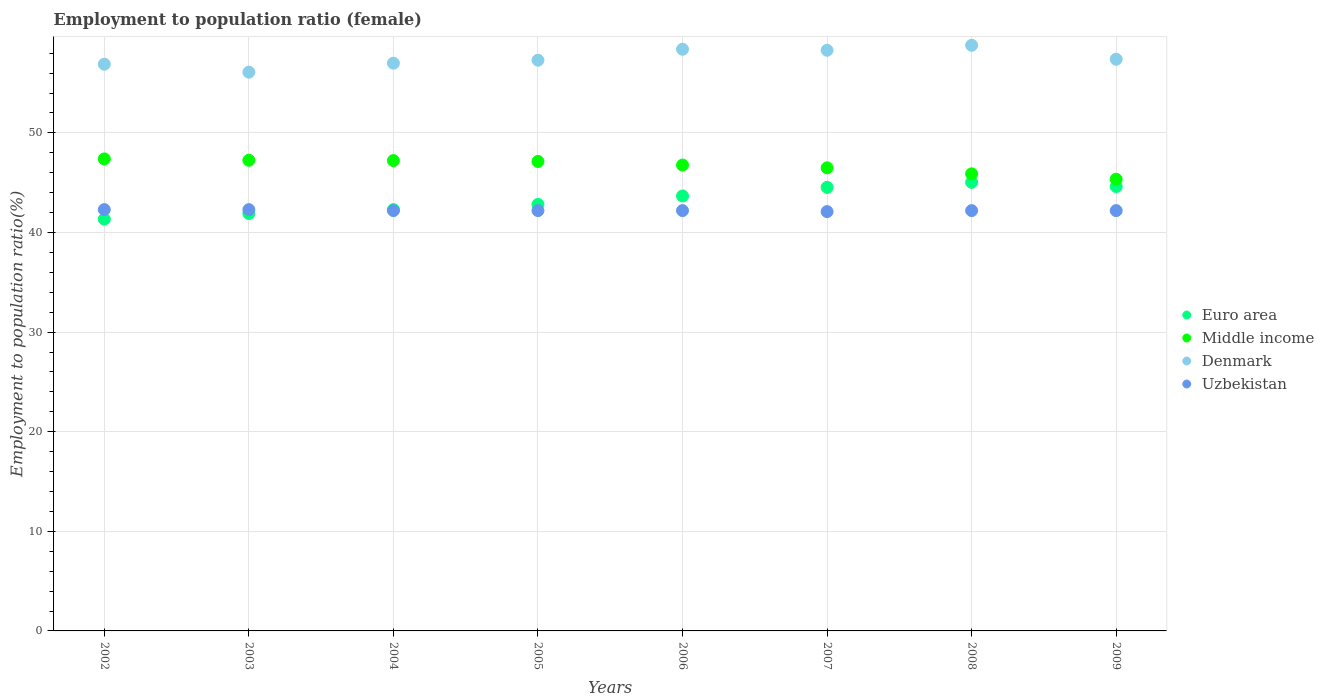How many different coloured dotlines are there?
Your response must be concise. 4. What is the employment to population ratio in Middle income in 2003?
Your answer should be compact. 47.26. Across all years, what is the maximum employment to population ratio in Uzbekistan?
Your response must be concise. 42.3. Across all years, what is the minimum employment to population ratio in Middle income?
Make the answer very short. 45.35. In which year was the employment to population ratio in Denmark minimum?
Provide a succinct answer. 2003. What is the total employment to population ratio in Uzbekistan in the graph?
Ensure brevity in your answer.  337.7. What is the difference between the employment to population ratio in Middle income in 2003 and that in 2004?
Offer a very short reply. 0.04. What is the difference between the employment to population ratio in Euro area in 2006 and the employment to population ratio in Denmark in 2009?
Provide a short and direct response. -13.73. What is the average employment to population ratio in Uzbekistan per year?
Your response must be concise. 42.21. In the year 2005, what is the difference between the employment to population ratio in Uzbekistan and employment to population ratio in Middle income?
Your answer should be compact. -4.93. In how many years, is the employment to population ratio in Denmark greater than 26 %?
Your answer should be compact. 8. What is the ratio of the employment to population ratio in Euro area in 2006 to that in 2009?
Keep it short and to the point. 0.98. Is the employment to population ratio in Denmark in 2004 less than that in 2005?
Ensure brevity in your answer.  Yes. Is the difference between the employment to population ratio in Uzbekistan in 2008 and 2009 greater than the difference between the employment to population ratio in Middle income in 2008 and 2009?
Offer a terse response. No. What is the difference between the highest and the second highest employment to population ratio in Uzbekistan?
Ensure brevity in your answer.  0. What is the difference between the highest and the lowest employment to population ratio in Middle income?
Make the answer very short. 2.04. Is the sum of the employment to population ratio in Denmark in 2003 and 2005 greater than the maximum employment to population ratio in Uzbekistan across all years?
Offer a terse response. Yes. Is the employment to population ratio in Middle income strictly less than the employment to population ratio in Uzbekistan over the years?
Give a very brief answer. No. How many dotlines are there?
Offer a terse response. 4. Are the values on the major ticks of Y-axis written in scientific E-notation?
Offer a terse response. No. Does the graph contain any zero values?
Provide a short and direct response. No. Where does the legend appear in the graph?
Offer a terse response. Center right. How many legend labels are there?
Your answer should be compact. 4. What is the title of the graph?
Ensure brevity in your answer.  Employment to population ratio (female). What is the label or title of the X-axis?
Your answer should be very brief. Years. What is the Employment to population ratio(%) in Euro area in 2002?
Give a very brief answer. 41.34. What is the Employment to population ratio(%) of Middle income in 2002?
Offer a very short reply. 47.39. What is the Employment to population ratio(%) in Denmark in 2002?
Provide a succinct answer. 56.9. What is the Employment to population ratio(%) in Uzbekistan in 2002?
Offer a very short reply. 42.3. What is the Employment to population ratio(%) in Euro area in 2003?
Keep it short and to the point. 41.91. What is the Employment to population ratio(%) of Middle income in 2003?
Your response must be concise. 47.26. What is the Employment to population ratio(%) of Denmark in 2003?
Keep it short and to the point. 56.1. What is the Employment to population ratio(%) of Uzbekistan in 2003?
Provide a succinct answer. 42.3. What is the Employment to population ratio(%) of Euro area in 2004?
Your response must be concise. 42.3. What is the Employment to population ratio(%) of Middle income in 2004?
Offer a terse response. 47.22. What is the Employment to population ratio(%) in Denmark in 2004?
Keep it short and to the point. 57. What is the Employment to population ratio(%) in Uzbekistan in 2004?
Give a very brief answer. 42.2. What is the Employment to population ratio(%) of Euro area in 2005?
Ensure brevity in your answer.  42.82. What is the Employment to population ratio(%) in Middle income in 2005?
Provide a succinct answer. 47.13. What is the Employment to population ratio(%) in Denmark in 2005?
Provide a succinct answer. 57.3. What is the Employment to population ratio(%) of Uzbekistan in 2005?
Provide a succinct answer. 42.2. What is the Employment to population ratio(%) of Euro area in 2006?
Your response must be concise. 43.67. What is the Employment to population ratio(%) in Middle income in 2006?
Your response must be concise. 46.77. What is the Employment to population ratio(%) in Denmark in 2006?
Your response must be concise. 58.4. What is the Employment to population ratio(%) in Uzbekistan in 2006?
Offer a terse response. 42.2. What is the Employment to population ratio(%) of Euro area in 2007?
Your answer should be very brief. 44.53. What is the Employment to population ratio(%) in Middle income in 2007?
Offer a terse response. 46.49. What is the Employment to population ratio(%) in Denmark in 2007?
Give a very brief answer. 58.3. What is the Employment to population ratio(%) in Uzbekistan in 2007?
Provide a short and direct response. 42.1. What is the Employment to population ratio(%) of Euro area in 2008?
Offer a very short reply. 45.04. What is the Employment to population ratio(%) of Middle income in 2008?
Give a very brief answer. 45.89. What is the Employment to population ratio(%) of Denmark in 2008?
Your response must be concise. 58.8. What is the Employment to population ratio(%) in Uzbekistan in 2008?
Your answer should be compact. 42.2. What is the Employment to population ratio(%) of Euro area in 2009?
Give a very brief answer. 44.62. What is the Employment to population ratio(%) of Middle income in 2009?
Your response must be concise. 45.35. What is the Employment to population ratio(%) of Denmark in 2009?
Ensure brevity in your answer.  57.4. What is the Employment to population ratio(%) in Uzbekistan in 2009?
Give a very brief answer. 42.2. Across all years, what is the maximum Employment to population ratio(%) in Euro area?
Ensure brevity in your answer.  45.04. Across all years, what is the maximum Employment to population ratio(%) in Middle income?
Offer a terse response. 47.39. Across all years, what is the maximum Employment to population ratio(%) of Denmark?
Your answer should be very brief. 58.8. Across all years, what is the maximum Employment to population ratio(%) in Uzbekistan?
Your answer should be very brief. 42.3. Across all years, what is the minimum Employment to population ratio(%) in Euro area?
Keep it short and to the point. 41.34. Across all years, what is the minimum Employment to population ratio(%) in Middle income?
Make the answer very short. 45.35. Across all years, what is the minimum Employment to population ratio(%) in Denmark?
Your answer should be compact. 56.1. Across all years, what is the minimum Employment to population ratio(%) of Uzbekistan?
Give a very brief answer. 42.1. What is the total Employment to population ratio(%) in Euro area in the graph?
Ensure brevity in your answer.  346.23. What is the total Employment to population ratio(%) of Middle income in the graph?
Provide a short and direct response. 373.5. What is the total Employment to population ratio(%) in Denmark in the graph?
Offer a terse response. 460.2. What is the total Employment to population ratio(%) of Uzbekistan in the graph?
Your response must be concise. 337.7. What is the difference between the Employment to population ratio(%) of Euro area in 2002 and that in 2003?
Your answer should be very brief. -0.57. What is the difference between the Employment to population ratio(%) in Middle income in 2002 and that in 2003?
Offer a terse response. 0.13. What is the difference between the Employment to population ratio(%) of Euro area in 2002 and that in 2004?
Keep it short and to the point. -0.95. What is the difference between the Employment to population ratio(%) of Middle income in 2002 and that in 2004?
Your answer should be very brief. 0.17. What is the difference between the Employment to population ratio(%) of Euro area in 2002 and that in 2005?
Make the answer very short. -1.48. What is the difference between the Employment to population ratio(%) in Middle income in 2002 and that in 2005?
Make the answer very short. 0.25. What is the difference between the Employment to population ratio(%) in Euro area in 2002 and that in 2006?
Your answer should be compact. -2.33. What is the difference between the Employment to population ratio(%) in Middle income in 2002 and that in 2006?
Keep it short and to the point. 0.62. What is the difference between the Employment to population ratio(%) in Uzbekistan in 2002 and that in 2006?
Make the answer very short. 0.1. What is the difference between the Employment to population ratio(%) of Euro area in 2002 and that in 2007?
Make the answer very short. -3.19. What is the difference between the Employment to population ratio(%) in Middle income in 2002 and that in 2007?
Your response must be concise. 0.89. What is the difference between the Employment to population ratio(%) of Denmark in 2002 and that in 2007?
Provide a short and direct response. -1.4. What is the difference between the Employment to population ratio(%) of Uzbekistan in 2002 and that in 2007?
Provide a short and direct response. 0.2. What is the difference between the Employment to population ratio(%) of Euro area in 2002 and that in 2008?
Keep it short and to the point. -3.7. What is the difference between the Employment to population ratio(%) of Middle income in 2002 and that in 2008?
Offer a terse response. 1.5. What is the difference between the Employment to population ratio(%) of Denmark in 2002 and that in 2008?
Your answer should be very brief. -1.9. What is the difference between the Employment to population ratio(%) of Uzbekistan in 2002 and that in 2008?
Make the answer very short. 0.1. What is the difference between the Employment to population ratio(%) in Euro area in 2002 and that in 2009?
Keep it short and to the point. -3.27. What is the difference between the Employment to population ratio(%) in Middle income in 2002 and that in 2009?
Offer a terse response. 2.04. What is the difference between the Employment to population ratio(%) in Denmark in 2002 and that in 2009?
Offer a very short reply. -0.5. What is the difference between the Employment to population ratio(%) of Uzbekistan in 2002 and that in 2009?
Provide a succinct answer. 0.1. What is the difference between the Employment to population ratio(%) in Euro area in 2003 and that in 2004?
Keep it short and to the point. -0.39. What is the difference between the Employment to population ratio(%) of Middle income in 2003 and that in 2004?
Offer a terse response. 0.04. What is the difference between the Employment to population ratio(%) in Denmark in 2003 and that in 2004?
Offer a terse response. -0.9. What is the difference between the Employment to population ratio(%) of Uzbekistan in 2003 and that in 2004?
Keep it short and to the point. 0.1. What is the difference between the Employment to population ratio(%) in Euro area in 2003 and that in 2005?
Provide a short and direct response. -0.91. What is the difference between the Employment to population ratio(%) in Middle income in 2003 and that in 2005?
Provide a succinct answer. 0.12. What is the difference between the Employment to population ratio(%) of Denmark in 2003 and that in 2005?
Your answer should be compact. -1.2. What is the difference between the Employment to population ratio(%) of Uzbekistan in 2003 and that in 2005?
Make the answer very short. 0.1. What is the difference between the Employment to population ratio(%) of Euro area in 2003 and that in 2006?
Provide a succinct answer. -1.76. What is the difference between the Employment to population ratio(%) of Middle income in 2003 and that in 2006?
Your answer should be very brief. 0.49. What is the difference between the Employment to population ratio(%) in Uzbekistan in 2003 and that in 2006?
Give a very brief answer. 0.1. What is the difference between the Employment to population ratio(%) of Euro area in 2003 and that in 2007?
Provide a short and direct response. -2.62. What is the difference between the Employment to population ratio(%) of Middle income in 2003 and that in 2007?
Offer a terse response. 0.76. What is the difference between the Employment to population ratio(%) of Euro area in 2003 and that in 2008?
Provide a short and direct response. -3.13. What is the difference between the Employment to population ratio(%) in Middle income in 2003 and that in 2008?
Keep it short and to the point. 1.37. What is the difference between the Employment to population ratio(%) in Euro area in 2003 and that in 2009?
Make the answer very short. -2.71. What is the difference between the Employment to population ratio(%) in Middle income in 2003 and that in 2009?
Offer a very short reply. 1.91. What is the difference between the Employment to population ratio(%) of Euro area in 2004 and that in 2005?
Offer a very short reply. -0.52. What is the difference between the Employment to population ratio(%) of Middle income in 2004 and that in 2005?
Give a very brief answer. 0.09. What is the difference between the Employment to population ratio(%) of Euro area in 2004 and that in 2006?
Ensure brevity in your answer.  -1.37. What is the difference between the Employment to population ratio(%) of Middle income in 2004 and that in 2006?
Your response must be concise. 0.45. What is the difference between the Employment to population ratio(%) of Denmark in 2004 and that in 2006?
Your response must be concise. -1.4. What is the difference between the Employment to population ratio(%) in Uzbekistan in 2004 and that in 2006?
Your response must be concise. 0. What is the difference between the Employment to population ratio(%) of Euro area in 2004 and that in 2007?
Your answer should be very brief. -2.24. What is the difference between the Employment to population ratio(%) of Middle income in 2004 and that in 2007?
Provide a short and direct response. 0.73. What is the difference between the Employment to population ratio(%) in Denmark in 2004 and that in 2007?
Your response must be concise. -1.3. What is the difference between the Employment to population ratio(%) in Uzbekistan in 2004 and that in 2007?
Keep it short and to the point. 0.1. What is the difference between the Employment to population ratio(%) in Euro area in 2004 and that in 2008?
Give a very brief answer. -2.74. What is the difference between the Employment to population ratio(%) of Middle income in 2004 and that in 2008?
Your answer should be very brief. 1.33. What is the difference between the Employment to population ratio(%) in Euro area in 2004 and that in 2009?
Keep it short and to the point. -2.32. What is the difference between the Employment to population ratio(%) of Middle income in 2004 and that in 2009?
Make the answer very short. 1.87. What is the difference between the Employment to population ratio(%) of Euro area in 2005 and that in 2006?
Make the answer very short. -0.85. What is the difference between the Employment to population ratio(%) of Middle income in 2005 and that in 2006?
Offer a very short reply. 0.36. What is the difference between the Employment to population ratio(%) in Denmark in 2005 and that in 2006?
Provide a succinct answer. -1.1. What is the difference between the Employment to population ratio(%) in Euro area in 2005 and that in 2007?
Your response must be concise. -1.71. What is the difference between the Employment to population ratio(%) of Middle income in 2005 and that in 2007?
Offer a terse response. 0.64. What is the difference between the Employment to population ratio(%) in Denmark in 2005 and that in 2007?
Your response must be concise. -1. What is the difference between the Employment to population ratio(%) of Euro area in 2005 and that in 2008?
Provide a short and direct response. -2.22. What is the difference between the Employment to population ratio(%) in Middle income in 2005 and that in 2008?
Keep it short and to the point. 1.24. What is the difference between the Employment to population ratio(%) of Denmark in 2005 and that in 2008?
Make the answer very short. -1.5. What is the difference between the Employment to population ratio(%) in Euro area in 2005 and that in 2009?
Make the answer very short. -1.8. What is the difference between the Employment to population ratio(%) of Middle income in 2005 and that in 2009?
Your answer should be very brief. 1.79. What is the difference between the Employment to population ratio(%) in Uzbekistan in 2005 and that in 2009?
Provide a succinct answer. 0. What is the difference between the Employment to population ratio(%) in Euro area in 2006 and that in 2007?
Keep it short and to the point. -0.86. What is the difference between the Employment to population ratio(%) of Middle income in 2006 and that in 2007?
Your answer should be compact. 0.28. What is the difference between the Employment to population ratio(%) of Euro area in 2006 and that in 2008?
Provide a succinct answer. -1.37. What is the difference between the Employment to population ratio(%) in Middle income in 2006 and that in 2008?
Give a very brief answer. 0.88. What is the difference between the Employment to population ratio(%) of Denmark in 2006 and that in 2008?
Provide a succinct answer. -0.4. What is the difference between the Employment to population ratio(%) in Uzbekistan in 2006 and that in 2008?
Your answer should be very brief. 0. What is the difference between the Employment to population ratio(%) of Euro area in 2006 and that in 2009?
Provide a succinct answer. -0.95. What is the difference between the Employment to population ratio(%) in Middle income in 2006 and that in 2009?
Your response must be concise. 1.42. What is the difference between the Employment to population ratio(%) in Denmark in 2006 and that in 2009?
Ensure brevity in your answer.  1. What is the difference between the Employment to population ratio(%) in Uzbekistan in 2006 and that in 2009?
Your answer should be very brief. 0. What is the difference between the Employment to population ratio(%) of Euro area in 2007 and that in 2008?
Offer a terse response. -0.51. What is the difference between the Employment to population ratio(%) of Middle income in 2007 and that in 2008?
Your answer should be compact. 0.6. What is the difference between the Employment to population ratio(%) of Euro area in 2007 and that in 2009?
Your answer should be compact. -0.08. What is the difference between the Employment to population ratio(%) of Middle income in 2007 and that in 2009?
Provide a succinct answer. 1.15. What is the difference between the Employment to population ratio(%) of Denmark in 2007 and that in 2009?
Your response must be concise. 0.9. What is the difference between the Employment to population ratio(%) of Uzbekistan in 2007 and that in 2009?
Your answer should be compact. -0.1. What is the difference between the Employment to population ratio(%) in Euro area in 2008 and that in 2009?
Ensure brevity in your answer.  0.42. What is the difference between the Employment to population ratio(%) of Middle income in 2008 and that in 2009?
Ensure brevity in your answer.  0.55. What is the difference between the Employment to population ratio(%) in Denmark in 2008 and that in 2009?
Keep it short and to the point. 1.4. What is the difference between the Employment to population ratio(%) of Euro area in 2002 and the Employment to population ratio(%) of Middle income in 2003?
Offer a terse response. -5.91. What is the difference between the Employment to population ratio(%) of Euro area in 2002 and the Employment to population ratio(%) of Denmark in 2003?
Keep it short and to the point. -14.76. What is the difference between the Employment to population ratio(%) in Euro area in 2002 and the Employment to population ratio(%) in Uzbekistan in 2003?
Provide a succinct answer. -0.96. What is the difference between the Employment to population ratio(%) of Middle income in 2002 and the Employment to population ratio(%) of Denmark in 2003?
Give a very brief answer. -8.71. What is the difference between the Employment to population ratio(%) in Middle income in 2002 and the Employment to population ratio(%) in Uzbekistan in 2003?
Provide a short and direct response. 5.09. What is the difference between the Employment to population ratio(%) in Denmark in 2002 and the Employment to population ratio(%) in Uzbekistan in 2003?
Provide a succinct answer. 14.6. What is the difference between the Employment to population ratio(%) in Euro area in 2002 and the Employment to population ratio(%) in Middle income in 2004?
Provide a short and direct response. -5.88. What is the difference between the Employment to population ratio(%) in Euro area in 2002 and the Employment to population ratio(%) in Denmark in 2004?
Your answer should be compact. -15.66. What is the difference between the Employment to population ratio(%) in Euro area in 2002 and the Employment to population ratio(%) in Uzbekistan in 2004?
Offer a terse response. -0.86. What is the difference between the Employment to population ratio(%) in Middle income in 2002 and the Employment to population ratio(%) in Denmark in 2004?
Provide a short and direct response. -9.61. What is the difference between the Employment to population ratio(%) of Middle income in 2002 and the Employment to population ratio(%) of Uzbekistan in 2004?
Provide a short and direct response. 5.19. What is the difference between the Employment to population ratio(%) in Euro area in 2002 and the Employment to population ratio(%) in Middle income in 2005?
Provide a succinct answer. -5.79. What is the difference between the Employment to population ratio(%) in Euro area in 2002 and the Employment to population ratio(%) in Denmark in 2005?
Keep it short and to the point. -15.96. What is the difference between the Employment to population ratio(%) of Euro area in 2002 and the Employment to population ratio(%) of Uzbekistan in 2005?
Keep it short and to the point. -0.86. What is the difference between the Employment to population ratio(%) of Middle income in 2002 and the Employment to population ratio(%) of Denmark in 2005?
Offer a very short reply. -9.91. What is the difference between the Employment to population ratio(%) in Middle income in 2002 and the Employment to population ratio(%) in Uzbekistan in 2005?
Your response must be concise. 5.19. What is the difference between the Employment to population ratio(%) in Denmark in 2002 and the Employment to population ratio(%) in Uzbekistan in 2005?
Offer a terse response. 14.7. What is the difference between the Employment to population ratio(%) of Euro area in 2002 and the Employment to population ratio(%) of Middle income in 2006?
Provide a short and direct response. -5.43. What is the difference between the Employment to population ratio(%) of Euro area in 2002 and the Employment to population ratio(%) of Denmark in 2006?
Keep it short and to the point. -17.06. What is the difference between the Employment to population ratio(%) in Euro area in 2002 and the Employment to population ratio(%) in Uzbekistan in 2006?
Give a very brief answer. -0.86. What is the difference between the Employment to population ratio(%) of Middle income in 2002 and the Employment to population ratio(%) of Denmark in 2006?
Offer a very short reply. -11.01. What is the difference between the Employment to population ratio(%) in Middle income in 2002 and the Employment to population ratio(%) in Uzbekistan in 2006?
Provide a succinct answer. 5.19. What is the difference between the Employment to population ratio(%) in Denmark in 2002 and the Employment to population ratio(%) in Uzbekistan in 2006?
Keep it short and to the point. 14.7. What is the difference between the Employment to population ratio(%) of Euro area in 2002 and the Employment to population ratio(%) of Middle income in 2007?
Offer a terse response. -5.15. What is the difference between the Employment to population ratio(%) of Euro area in 2002 and the Employment to population ratio(%) of Denmark in 2007?
Provide a succinct answer. -16.96. What is the difference between the Employment to population ratio(%) in Euro area in 2002 and the Employment to population ratio(%) in Uzbekistan in 2007?
Offer a very short reply. -0.76. What is the difference between the Employment to population ratio(%) in Middle income in 2002 and the Employment to population ratio(%) in Denmark in 2007?
Offer a very short reply. -10.91. What is the difference between the Employment to population ratio(%) in Middle income in 2002 and the Employment to population ratio(%) in Uzbekistan in 2007?
Provide a succinct answer. 5.29. What is the difference between the Employment to population ratio(%) of Denmark in 2002 and the Employment to population ratio(%) of Uzbekistan in 2007?
Keep it short and to the point. 14.8. What is the difference between the Employment to population ratio(%) of Euro area in 2002 and the Employment to population ratio(%) of Middle income in 2008?
Your response must be concise. -4.55. What is the difference between the Employment to population ratio(%) of Euro area in 2002 and the Employment to population ratio(%) of Denmark in 2008?
Ensure brevity in your answer.  -17.46. What is the difference between the Employment to population ratio(%) in Euro area in 2002 and the Employment to population ratio(%) in Uzbekistan in 2008?
Provide a succinct answer. -0.86. What is the difference between the Employment to population ratio(%) in Middle income in 2002 and the Employment to population ratio(%) in Denmark in 2008?
Keep it short and to the point. -11.41. What is the difference between the Employment to population ratio(%) of Middle income in 2002 and the Employment to population ratio(%) of Uzbekistan in 2008?
Offer a very short reply. 5.19. What is the difference between the Employment to population ratio(%) of Denmark in 2002 and the Employment to population ratio(%) of Uzbekistan in 2008?
Your answer should be very brief. 14.7. What is the difference between the Employment to population ratio(%) of Euro area in 2002 and the Employment to population ratio(%) of Middle income in 2009?
Provide a succinct answer. -4. What is the difference between the Employment to population ratio(%) in Euro area in 2002 and the Employment to population ratio(%) in Denmark in 2009?
Your response must be concise. -16.06. What is the difference between the Employment to population ratio(%) of Euro area in 2002 and the Employment to population ratio(%) of Uzbekistan in 2009?
Your response must be concise. -0.86. What is the difference between the Employment to population ratio(%) in Middle income in 2002 and the Employment to population ratio(%) in Denmark in 2009?
Your answer should be very brief. -10.01. What is the difference between the Employment to population ratio(%) in Middle income in 2002 and the Employment to population ratio(%) in Uzbekistan in 2009?
Offer a very short reply. 5.19. What is the difference between the Employment to population ratio(%) in Denmark in 2002 and the Employment to population ratio(%) in Uzbekistan in 2009?
Make the answer very short. 14.7. What is the difference between the Employment to population ratio(%) of Euro area in 2003 and the Employment to population ratio(%) of Middle income in 2004?
Your answer should be very brief. -5.31. What is the difference between the Employment to population ratio(%) in Euro area in 2003 and the Employment to population ratio(%) in Denmark in 2004?
Ensure brevity in your answer.  -15.09. What is the difference between the Employment to population ratio(%) in Euro area in 2003 and the Employment to population ratio(%) in Uzbekistan in 2004?
Make the answer very short. -0.29. What is the difference between the Employment to population ratio(%) in Middle income in 2003 and the Employment to population ratio(%) in Denmark in 2004?
Give a very brief answer. -9.74. What is the difference between the Employment to population ratio(%) in Middle income in 2003 and the Employment to population ratio(%) in Uzbekistan in 2004?
Provide a short and direct response. 5.06. What is the difference between the Employment to population ratio(%) of Denmark in 2003 and the Employment to population ratio(%) of Uzbekistan in 2004?
Ensure brevity in your answer.  13.9. What is the difference between the Employment to population ratio(%) in Euro area in 2003 and the Employment to population ratio(%) in Middle income in 2005?
Ensure brevity in your answer.  -5.23. What is the difference between the Employment to population ratio(%) of Euro area in 2003 and the Employment to population ratio(%) of Denmark in 2005?
Provide a short and direct response. -15.39. What is the difference between the Employment to population ratio(%) of Euro area in 2003 and the Employment to population ratio(%) of Uzbekistan in 2005?
Offer a terse response. -0.29. What is the difference between the Employment to population ratio(%) of Middle income in 2003 and the Employment to population ratio(%) of Denmark in 2005?
Give a very brief answer. -10.04. What is the difference between the Employment to population ratio(%) in Middle income in 2003 and the Employment to population ratio(%) in Uzbekistan in 2005?
Offer a very short reply. 5.06. What is the difference between the Employment to population ratio(%) of Euro area in 2003 and the Employment to population ratio(%) of Middle income in 2006?
Give a very brief answer. -4.86. What is the difference between the Employment to population ratio(%) in Euro area in 2003 and the Employment to population ratio(%) in Denmark in 2006?
Your response must be concise. -16.49. What is the difference between the Employment to population ratio(%) in Euro area in 2003 and the Employment to population ratio(%) in Uzbekistan in 2006?
Give a very brief answer. -0.29. What is the difference between the Employment to population ratio(%) in Middle income in 2003 and the Employment to population ratio(%) in Denmark in 2006?
Give a very brief answer. -11.14. What is the difference between the Employment to population ratio(%) of Middle income in 2003 and the Employment to population ratio(%) of Uzbekistan in 2006?
Your answer should be compact. 5.06. What is the difference between the Employment to population ratio(%) of Euro area in 2003 and the Employment to population ratio(%) of Middle income in 2007?
Your answer should be very brief. -4.59. What is the difference between the Employment to population ratio(%) of Euro area in 2003 and the Employment to population ratio(%) of Denmark in 2007?
Offer a very short reply. -16.39. What is the difference between the Employment to population ratio(%) in Euro area in 2003 and the Employment to population ratio(%) in Uzbekistan in 2007?
Offer a very short reply. -0.19. What is the difference between the Employment to population ratio(%) in Middle income in 2003 and the Employment to population ratio(%) in Denmark in 2007?
Provide a succinct answer. -11.04. What is the difference between the Employment to population ratio(%) of Middle income in 2003 and the Employment to population ratio(%) of Uzbekistan in 2007?
Keep it short and to the point. 5.16. What is the difference between the Employment to population ratio(%) of Denmark in 2003 and the Employment to population ratio(%) of Uzbekistan in 2007?
Make the answer very short. 14. What is the difference between the Employment to population ratio(%) in Euro area in 2003 and the Employment to population ratio(%) in Middle income in 2008?
Provide a short and direct response. -3.98. What is the difference between the Employment to population ratio(%) in Euro area in 2003 and the Employment to population ratio(%) in Denmark in 2008?
Ensure brevity in your answer.  -16.89. What is the difference between the Employment to population ratio(%) in Euro area in 2003 and the Employment to population ratio(%) in Uzbekistan in 2008?
Provide a short and direct response. -0.29. What is the difference between the Employment to population ratio(%) in Middle income in 2003 and the Employment to population ratio(%) in Denmark in 2008?
Offer a very short reply. -11.54. What is the difference between the Employment to population ratio(%) of Middle income in 2003 and the Employment to population ratio(%) of Uzbekistan in 2008?
Offer a terse response. 5.06. What is the difference between the Employment to population ratio(%) in Denmark in 2003 and the Employment to population ratio(%) in Uzbekistan in 2008?
Keep it short and to the point. 13.9. What is the difference between the Employment to population ratio(%) in Euro area in 2003 and the Employment to population ratio(%) in Middle income in 2009?
Your response must be concise. -3.44. What is the difference between the Employment to population ratio(%) in Euro area in 2003 and the Employment to population ratio(%) in Denmark in 2009?
Ensure brevity in your answer.  -15.49. What is the difference between the Employment to population ratio(%) of Euro area in 2003 and the Employment to population ratio(%) of Uzbekistan in 2009?
Make the answer very short. -0.29. What is the difference between the Employment to population ratio(%) in Middle income in 2003 and the Employment to population ratio(%) in Denmark in 2009?
Your response must be concise. -10.14. What is the difference between the Employment to population ratio(%) in Middle income in 2003 and the Employment to population ratio(%) in Uzbekistan in 2009?
Keep it short and to the point. 5.06. What is the difference between the Employment to population ratio(%) in Euro area in 2004 and the Employment to population ratio(%) in Middle income in 2005?
Offer a terse response. -4.84. What is the difference between the Employment to population ratio(%) of Euro area in 2004 and the Employment to population ratio(%) of Denmark in 2005?
Keep it short and to the point. -15. What is the difference between the Employment to population ratio(%) in Euro area in 2004 and the Employment to population ratio(%) in Uzbekistan in 2005?
Give a very brief answer. 0.1. What is the difference between the Employment to population ratio(%) of Middle income in 2004 and the Employment to population ratio(%) of Denmark in 2005?
Your answer should be very brief. -10.08. What is the difference between the Employment to population ratio(%) in Middle income in 2004 and the Employment to population ratio(%) in Uzbekistan in 2005?
Provide a succinct answer. 5.02. What is the difference between the Employment to population ratio(%) of Euro area in 2004 and the Employment to population ratio(%) of Middle income in 2006?
Your answer should be compact. -4.47. What is the difference between the Employment to population ratio(%) in Euro area in 2004 and the Employment to population ratio(%) in Denmark in 2006?
Your answer should be very brief. -16.1. What is the difference between the Employment to population ratio(%) of Euro area in 2004 and the Employment to population ratio(%) of Uzbekistan in 2006?
Your response must be concise. 0.1. What is the difference between the Employment to population ratio(%) in Middle income in 2004 and the Employment to population ratio(%) in Denmark in 2006?
Keep it short and to the point. -11.18. What is the difference between the Employment to population ratio(%) in Middle income in 2004 and the Employment to population ratio(%) in Uzbekistan in 2006?
Provide a succinct answer. 5.02. What is the difference between the Employment to population ratio(%) of Denmark in 2004 and the Employment to population ratio(%) of Uzbekistan in 2006?
Your answer should be compact. 14.8. What is the difference between the Employment to population ratio(%) of Euro area in 2004 and the Employment to population ratio(%) of Middle income in 2007?
Ensure brevity in your answer.  -4.2. What is the difference between the Employment to population ratio(%) of Euro area in 2004 and the Employment to population ratio(%) of Denmark in 2007?
Offer a terse response. -16. What is the difference between the Employment to population ratio(%) of Euro area in 2004 and the Employment to population ratio(%) of Uzbekistan in 2007?
Offer a terse response. 0.2. What is the difference between the Employment to population ratio(%) in Middle income in 2004 and the Employment to population ratio(%) in Denmark in 2007?
Your answer should be compact. -11.08. What is the difference between the Employment to population ratio(%) of Middle income in 2004 and the Employment to population ratio(%) of Uzbekistan in 2007?
Ensure brevity in your answer.  5.12. What is the difference between the Employment to population ratio(%) of Euro area in 2004 and the Employment to population ratio(%) of Middle income in 2008?
Offer a terse response. -3.59. What is the difference between the Employment to population ratio(%) of Euro area in 2004 and the Employment to population ratio(%) of Denmark in 2008?
Your answer should be compact. -16.5. What is the difference between the Employment to population ratio(%) of Euro area in 2004 and the Employment to population ratio(%) of Uzbekistan in 2008?
Your answer should be very brief. 0.1. What is the difference between the Employment to population ratio(%) in Middle income in 2004 and the Employment to population ratio(%) in Denmark in 2008?
Your answer should be very brief. -11.58. What is the difference between the Employment to population ratio(%) of Middle income in 2004 and the Employment to population ratio(%) of Uzbekistan in 2008?
Your response must be concise. 5.02. What is the difference between the Employment to population ratio(%) in Denmark in 2004 and the Employment to population ratio(%) in Uzbekistan in 2008?
Make the answer very short. 14.8. What is the difference between the Employment to population ratio(%) of Euro area in 2004 and the Employment to population ratio(%) of Middle income in 2009?
Provide a short and direct response. -3.05. What is the difference between the Employment to population ratio(%) in Euro area in 2004 and the Employment to population ratio(%) in Denmark in 2009?
Your answer should be compact. -15.1. What is the difference between the Employment to population ratio(%) of Euro area in 2004 and the Employment to population ratio(%) of Uzbekistan in 2009?
Keep it short and to the point. 0.1. What is the difference between the Employment to population ratio(%) of Middle income in 2004 and the Employment to population ratio(%) of Denmark in 2009?
Keep it short and to the point. -10.18. What is the difference between the Employment to population ratio(%) of Middle income in 2004 and the Employment to population ratio(%) of Uzbekistan in 2009?
Keep it short and to the point. 5.02. What is the difference between the Employment to population ratio(%) of Denmark in 2004 and the Employment to population ratio(%) of Uzbekistan in 2009?
Ensure brevity in your answer.  14.8. What is the difference between the Employment to population ratio(%) of Euro area in 2005 and the Employment to population ratio(%) of Middle income in 2006?
Your response must be concise. -3.95. What is the difference between the Employment to population ratio(%) of Euro area in 2005 and the Employment to population ratio(%) of Denmark in 2006?
Keep it short and to the point. -15.58. What is the difference between the Employment to population ratio(%) in Euro area in 2005 and the Employment to population ratio(%) in Uzbekistan in 2006?
Provide a short and direct response. 0.62. What is the difference between the Employment to population ratio(%) in Middle income in 2005 and the Employment to population ratio(%) in Denmark in 2006?
Your response must be concise. -11.27. What is the difference between the Employment to population ratio(%) of Middle income in 2005 and the Employment to population ratio(%) of Uzbekistan in 2006?
Make the answer very short. 4.93. What is the difference between the Employment to population ratio(%) in Denmark in 2005 and the Employment to population ratio(%) in Uzbekistan in 2006?
Give a very brief answer. 15.1. What is the difference between the Employment to population ratio(%) in Euro area in 2005 and the Employment to population ratio(%) in Middle income in 2007?
Offer a very short reply. -3.67. What is the difference between the Employment to population ratio(%) in Euro area in 2005 and the Employment to population ratio(%) in Denmark in 2007?
Offer a terse response. -15.48. What is the difference between the Employment to population ratio(%) of Euro area in 2005 and the Employment to population ratio(%) of Uzbekistan in 2007?
Your response must be concise. 0.72. What is the difference between the Employment to population ratio(%) of Middle income in 2005 and the Employment to population ratio(%) of Denmark in 2007?
Provide a succinct answer. -11.17. What is the difference between the Employment to population ratio(%) in Middle income in 2005 and the Employment to population ratio(%) in Uzbekistan in 2007?
Give a very brief answer. 5.03. What is the difference between the Employment to population ratio(%) of Denmark in 2005 and the Employment to population ratio(%) of Uzbekistan in 2007?
Provide a succinct answer. 15.2. What is the difference between the Employment to population ratio(%) in Euro area in 2005 and the Employment to population ratio(%) in Middle income in 2008?
Your response must be concise. -3.07. What is the difference between the Employment to population ratio(%) in Euro area in 2005 and the Employment to population ratio(%) in Denmark in 2008?
Ensure brevity in your answer.  -15.98. What is the difference between the Employment to population ratio(%) of Euro area in 2005 and the Employment to population ratio(%) of Uzbekistan in 2008?
Provide a short and direct response. 0.62. What is the difference between the Employment to population ratio(%) of Middle income in 2005 and the Employment to population ratio(%) of Denmark in 2008?
Provide a succinct answer. -11.67. What is the difference between the Employment to population ratio(%) of Middle income in 2005 and the Employment to population ratio(%) of Uzbekistan in 2008?
Your answer should be very brief. 4.93. What is the difference between the Employment to population ratio(%) in Denmark in 2005 and the Employment to population ratio(%) in Uzbekistan in 2008?
Your answer should be very brief. 15.1. What is the difference between the Employment to population ratio(%) in Euro area in 2005 and the Employment to population ratio(%) in Middle income in 2009?
Offer a terse response. -2.53. What is the difference between the Employment to population ratio(%) in Euro area in 2005 and the Employment to population ratio(%) in Denmark in 2009?
Give a very brief answer. -14.58. What is the difference between the Employment to population ratio(%) of Euro area in 2005 and the Employment to population ratio(%) of Uzbekistan in 2009?
Keep it short and to the point. 0.62. What is the difference between the Employment to population ratio(%) of Middle income in 2005 and the Employment to population ratio(%) of Denmark in 2009?
Offer a terse response. -10.27. What is the difference between the Employment to population ratio(%) in Middle income in 2005 and the Employment to population ratio(%) in Uzbekistan in 2009?
Give a very brief answer. 4.93. What is the difference between the Employment to population ratio(%) in Denmark in 2005 and the Employment to population ratio(%) in Uzbekistan in 2009?
Offer a terse response. 15.1. What is the difference between the Employment to population ratio(%) of Euro area in 2006 and the Employment to population ratio(%) of Middle income in 2007?
Offer a terse response. -2.82. What is the difference between the Employment to population ratio(%) of Euro area in 2006 and the Employment to population ratio(%) of Denmark in 2007?
Give a very brief answer. -14.63. What is the difference between the Employment to population ratio(%) of Euro area in 2006 and the Employment to population ratio(%) of Uzbekistan in 2007?
Provide a succinct answer. 1.57. What is the difference between the Employment to population ratio(%) of Middle income in 2006 and the Employment to population ratio(%) of Denmark in 2007?
Your answer should be compact. -11.53. What is the difference between the Employment to population ratio(%) in Middle income in 2006 and the Employment to population ratio(%) in Uzbekistan in 2007?
Provide a succinct answer. 4.67. What is the difference between the Employment to population ratio(%) in Denmark in 2006 and the Employment to population ratio(%) in Uzbekistan in 2007?
Your answer should be very brief. 16.3. What is the difference between the Employment to population ratio(%) of Euro area in 2006 and the Employment to population ratio(%) of Middle income in 2008?
Your answer should be very brief. -2.22. What is the difference between the Employment to population ratio(%) of Euro area in 2006 and the Employment to population ratio(%) of Denmark in 2008?
Your answer should be compact. -15.13. What is the difference between the Employment to population ratio(%) of Euro area in 2006 and the Employment to population ratio(%) of Uzbekistan in 2008?
Your response must be concise. 1.47. What is the difference between the Employment to population ratio(%) in Middle income in 2006 and the Employment to population ratio(%) in Denmark in 2008?
Your answer should be very brief. -12.03. What is the difference between the Employment to population ratio(%) in Middle income in 2006 and the Employment to population ratio(%) in Uzbekistan in 2008?
Offer a very short reply. 4.57. What is the difference between the Employment to population ratio(%) of Euro area in 2006 and the Employment to population ratio(%) of Middle income in 2009?
Offer a terse response. -1.67. What is the difference between the Employment to population ratio(%) in Euro area in 2006 and the Employment to population ratio(%) in Denmark in 2009?
Provide a short and direct response. -13.73. What is the difference between the Employment to population ratio(%) in Euro area in 2006 and the Employment to population ratio(%) in Uzbekistan in 2009?
Offer a terse response. 1.47. What is the difference between the Employment to population ratio(%) of Middle income in 2006 and the Employment to population ratio(%) of Denmark in 2009?
Ensure brevity in your answer.  -10.63. What is the difference between the Employment to population ratio(%) in Middle income in 2006 and the Employment to population ratio(%) in Uzbekistan in 2009?
Offer a very short reply. 4.57. What is the difference between the Employment to population ratio(%) in Denmark in 2006 and the Employment to population ratio(%) in Uzbekistan in 2009?
Make the answer very short. 16.2. What is the difference between the Employment to population ratio(%) in Euro area in 2007 and the Employment to population ratio(%) in Middle income in 2008?
Your answer should be very brief. -1.36. What is the difference between the Employment to population ratio(%) in Euro area in 2007 and the Employment to population ratio(%) in Denmark in 2008?
Provide a succinct answer. -14.27. What is the difference between the Employment to population ratio(%) in Euro area in 2007 and the Employment to population ratio(%) in Uzbekistan in 2008?
Your response must be concise. 2.33. What is the difference between the Employment to population ratio(%) in Middle income in 2007 and the Employment to population ratio(%) in Denmark in 2008?
Keep it short and to the point. -12.31. What is the difference between the Employment to population ratio(%) in Middle income in 2007 and the Employment to population ratio(%) in Uzbekistan in 2008?
Offer a terse response. 4.29. What is the difference between the Employment to population ratio(%) in Denmark in 2007 and the Employment to population ratio(%) in Uzbekistan in 2008?
Provide a succinct answer. 16.1. What is the difference between the Employment to population ratio(%) in Euro area in 2007 and the Employment to population ratio(%) in Middle income in 2009?
Offer a very short reply. -0.81. What is the difference between the Employment to population ratio(%) of Euro area in 2007 and the Employment to population ratio(%) of Denmark in 2009?
Keep it short and to the point. -12.87. What is the difference between the Employment to population ratio(%) of Euro area in 2007 and the Employment to population ratio(%) of Uzbekistan in 2009?
Offer a terse response. 2.33. What is the difference between the Employment to population ratio(%) in Middle income in 2007 and the Employment to population ratio(%) in Denmark in 2009?
Give a very brief answer. -10.91. What is the difference between the Employment to population ratio(%) in Middle income in 2007 and the Employment to population ratio(%) in Uzbekistan in 2009?
Offer a very short reply. 4.29. What is the difference between the Employment to population ratio(%) in Denmark in 2007 and the Employment to population ratio(%) in Uzbekistan in 2009?
Your answer should be compact. 16.1. What is the difference between the Employment to population ratio(%) of Euro area in 2008 and the Employment to population ratio(%) of Middle income in 2009?
Provide a short and direct response. -0.31. What is the difference between the Employment to population ratio(%) of Euro area in 2008 and the Employment to population ratio(%) of Denmark in 2009?
Your response must be concise. -12.36. What is the difference between the Employment to population ratio(%) of Euro area in 2008 and the Employment to population ratio(%) of Uzbekistan in 2009?
Give a very brief answer. 2.84. What is the difference between the Employment to population ratio(%) in Middle income in 2008 and the Employment to population ratio(%) in Denmark in 2009?
Ensure brevity in your answer.  -11.51. What is the difference between the Employment to population ratio(%) of Middle income in 2008 and the Employment to population ratio(%) of Uzbekistan in 2009?
Your answer should be very brief. 3.69. What is the difference between the Employment to population ratio(%) of Denmark in 2008 and the Employment to population ratio(%) of Uzbekistan in 2009?
Your answer should be compact. 16.6. What is the average Employment to population ratio(%) of Euro area per year?
Provide a succinct answer. 43.28. What is the average Employment to population ratio(%) in Middle income per year?
Your answer should be compact. 46.69. What is the average Employment to population ratio(%) of Denmark per year?
Your response must be concise. 57.52. What is the average Employment to population ratio(%) of Uzbekistan per year?
Your response must be concise. 42.21. In the year 2002, what is the difference between the Employment to population ratio(%) in Euro area and Employment to population ratio(%) in Middle income?
Your response must be concise. -6.04. In the year 2002, what is the difference between the Employment to population ratio(%) in Euro area and Employment to population ratio(%) in Denmark?
Give a very brief answer. -15.56. In the year 2002, what is the difference between the Employment to population ratio(%) of Euro area and Employment to population ratio(%) of Uzbekistan?
Keep it short and to the point. -0.96. In the year 2002, what is the difference between the Employment to population ratio(%) in Middle income and Employment to population ratio(%) in Denmark?
Offer a very short reply. -9.51. In the year 2002, what is the difference between the Employment to population ratio(%) of Middle income and Employment to population ratio(%) of Uzbekistan?
Your answer should be compact. 5.09. In the year 2003, what is the difference between the Employment to population ratio(%) of Euro area and Employment to population ratio(%) of Middle income?
Keep it short and to the point. -5.35. In the year 2003, what is the difference between the Employment to population ratio(%) of Euro area and Employment to population ratio(%) of Denmark?
Make the answer very short. -14.19. In the year 2003, what is the difference between the Employment to population ratio(%) of Euro area and Employment to population ratio(%) of Uzbekistan?
Offer a very short reply. -0.39. In the year 2003, what is the difference between the Employment to population ratio(%) of Middle income and Employment to population ratio(%) of Denmark?
Offer a terse response. -8.84. In the year 2003, what is the difference between the Employment to population ratio(%) in Middle income and Employment to population ratio(%) in Uzbekistan?
Your answer should be compact. 4.96. In the year 2004, what is the difference between the Employment to population ratio(%) of Euro area and Employment to population ratio(%) of Middle income?
Your answer should be very brief. -4.92. In the year 2004, what is the difference between the Employment to population ratio(%) of Euro area and Employment to population ratio(%) of Denmark?
Your answer should be compact. -14.7. In the year 2004, what is the difference between the Employment to population ratio(%) in Euro area and Employment to population ratio(%) in Uzbekistan?
Offer a terse response. 0.1. In the year 2004, what is the difference between the Employment to population ratio(%) of Middle income and Employment to population ratio(%) of Denmark?
Your answer should be very brief. -9.78. In the year 2004, what is the difference between the Employment to population ratio(%) in Middle income and Employment to population ratio(%) in Uzbekistan?
Offer a terse response. 5.02. In the year 2004, what is the difference between the Employment to population ratio(%) in Denmark and Employment to population ratio(%) in Uzbekistan?
Offer a terse response. 14.8. In the year 2005, what is the difference between the Employment to population ratio(%) in Euro area and Employment to population ratio(%) in Middle income?
Give a very brief answer. -4.31. In the year 2005, what is the difference between the Employment to population ratio(%) of Euro area and Employment to population ratio(%) of Denmark?
Provide a succinct answer. -14.48. In the year 2005, what is the difference between the Employment to population ratio(%) of Euro area and Employment to population ratio(%) of Uzbekistan?
Keep it short and to the point. 0.62. In the year 2005, what is the difference between the Employment to population ratio(%) in Middle income and Employment to population ratio(%) in Denmark?
Make the answer very short. -10.17. In the year 2005, what is the difference between the Employment to population ratio(%) in Middle income and Employment to population ratio(%) in Uzbekistan?
Ensure brevity in your answer.  4.93. In the year 2006, what is the difference between the Employment to population ratio(%) of Euro area and Employment to population ratio(%) of Middle income?
Make the answer very short. -3.1. In the year 2006, what is the difference between the Employment to population ratio(%) of Euro area and Employment to population ratio(%) of Denmark?
Provide a short and direct response. -14.73. In the year 2006, what is the difference between the Employment to population ratio(%) in Euro area and Employment to population ratio(%) in Uzbekistan?
Offer a terse response. 1.47. In the year 2006, what is the difference between the Employment to population ratio(%) of Middle income and Employment to population ratio(%) of Denmark?
Offer a terse response. -11.63. In the year 2006, what is the difference between the Employment to population ratio(%) in Middle income and Employment to population ratio(%) in Uzbekistan?
Your answer should be very brief. 4.57. In the year 2006, what is the difference between the Employment to population ratio(%) of Denmark and Employment to population ratio(%) of Uzbekistan?
Provide a succinct answer. 16.2. In the year 2007, what is the difference between the Employment to population ratio(%) in Euro area and Employment to population ratio(%) in Middle income?
Your answer should be very brief. -1.96. In the year 2007, what is the difference between the Employment to population ratio(%) of Euro area and Employment to population ratio(%) of Denmark?
Offer a terse response. -13.77. In the year 2007, what is the difference between the Employment to population ratio(%) in Euro area and Employment to population ratio(%) in Uzbekistan?
Make the answer very short. 2.43. In the year 2007, what is the difference between the Employment to population ratio(%) of Middle income and Employment to population ratio(%) of Denmark?
Give a very brief answer. -11.81. In the year 2007, what is the difference between the Employment to population ratio(%) of Middle income and Employment to population ratio(%) of Uzbekistan?
Offer a very short reply. 4.39. In the year 2007, what is the difference between the Employment to population ratio(%) in Denmark and Employment to population ratio(%) in Uzbekistan?
Keep it short and to the point. 16.2. In the year 2008, what is the difference between the Employment to population ratio(%) in Euro area and Employment to population ratio(%) in Middle income?
Provide a short and direct response. -0.85. In the year 2008, what is the difference between the Employment to population ratio(%) of Euro area and Employment to population ratio(%) of Denmark?
Ensure brevity in your answer.  -13.76. In the year 2008, what is the difference between the Employment to population ratio(%) in Euro area and Employment to population ratio(%) in Uzbekistan?
Make the answer very short. 2.84. In the year 2008, what is the difference between the Employment to population ratio(%) of Middle income and Employment to population ratio(%) of Denmark?
Ensure brevity in your answer.  -12.91. In the year 2008, what is the difference between the Employment to population ratio(%) of Middle income and Employment to population ratio(%) of Uzbekistan?
Offer a terse response. 3.69. In the year 2009, what is the difference between the Employment to population ratio(%) of Euro area and Employment to population ratio(%) of Middle income?
Ensure brevity in your answer.  -0.73. In the year 2009, what is the difference between the Employment to population ratio(%) of Euro area and Employment to population ratio(%) of Denmark?
Ensure brevity in your answer.  -12.78. In the year 2009, what is the difference between the Employment to population ratio(%) of Euro area and Employment to population ratio(%) of Uzbekistan?
Ensure brevity in your answer.  2.42. In the year 2009, what is the difference between the Employment to population ratio(%) of Middle income and Employment to population ratio(%) of Denmark?
Your answer should be very brief. -12.05. In the year 2009, what is the difference between the Employment to population ratio(%) of Middle income and Employment to population ratio(%) of Uzbekistan?
Make the answer very short. 3.15. In the year 2009, what is the difference between the Employment to population ratio(%) of Denmark and Employment to population ratio(%) of Uzbekistan?
Give a very brief answer. 15.2. What is the ratio of the Employment to population ratio(%) in Euro area in 2002 to that in 2003?
Provide a succinct answer. 0.99. What is the ratio of the Employment to population ratio(%) of Middle income in 2002 to that in 2003?
Give a very brief answer. 1. What is the ratio of the Employment to population ratio(%) of Denmark in 2002 to that in 2003?
Ensure brevity in your answer.  1.01. What is the ratio of the Employment to population ratio(%) of Uzbekistan in 2002 to that in 2003?
Your answer should be compact. 1. What is the ratio of the Employment to population ratio(%) of Euro area in 2002 to that in 2004?
Your answer should be very brief. 0.98. What is the ratio of the Employment to population ratio(%) of Middle income in 2002 to that in 2004?
Provide a short and direct response. 1. What is the ratio of the Employment to population ratio(%) in Uzbekistan in 2002 to that in 2004?
Provide a short and direct response. 1. What is the ratio of the Employment to population ratio(%) in Euro area in 2002 to that in 2005?
Offer a terse response. 0.97. What is the ratio of the Employment to population ratio(%) in Middle income in 2002 to that in 2005?
Your answer should be compact. 1.01. What is the ratio of the Employment to population ratio(%) in Uzbekistan in 2002 to that in 2005?
Your response must be concise. 1. What is the ratio of the Employment to population ratio(%) of Euro area in 2002 to that in 2006?
Offer a terse response. 0.95. What is the ratio of the Employment to population ratio(%) of Middle income in 2002 to that in 2006?
Provide a succinct answer. 1.01. What is the ratio of the Employment to population ratio(%) of Denmark in 2002 to that in 2006?
Ensure brevity in your answer.  0.97. What is the ratio of the Employment to population ratio(%) in Uzbekistan in 2002 to that in 2006?
Offer a very short reply. 1. What is the ratio of the Employment to population ratio(%) of Euro area in 2002 to that in 2007?
Make the answer very short. 0.93. What is the ratio of the Employment to population ratio(%) of Middle income in 2002 to that in 2007?
Your response must be concise. 1.02. What is the ratio of the Employment to population ratio(%) in Euro area in 2002 to that in 2008?
Keep it short and to the point. 0.92. What is the ratio of the Employment to population ratio(%) of Middle income in 2002 to that in 2008?
Ensure brevity in your answer.  1.03. What is the ratio of the Employment to population ratio(%) of Denmark in 2002 to that in 2008?
Your answer should be compact. 0.97. What is the ratio of the Employment to population ratio(%) in Uzbekistan in 2002 to that in 2008?
Your answer should be very brief. 1. What is the ratio of the Employment to population ratio(%) in Euro area in 2002 to that in 2009?
Give a very brief answer. 0.93. What is the ratio of the Employment to population ratio(%) in Middle income in 2002 to that in 2009?
Provide a succinct answer. 1.04. What is the ratio of the Employment to population ratio(%) of Euro area in 2003 to that in 2004?
Offer a very short reply. 0.99. What is the ratio of the Employment to population ratio(%) of Middle income in 2003 to that in 2004?
Offer a very short reply. 1. What is the ratio of the Employment to population ratio(%) in Denmark in 2003 to that in 2004?
Offer a very short reply. 0.98. What is the ratio of the Employment to population ratio(%) of Uzbekistan in 2003 to that in 2004?
Ensure brevity in your answer.  1. What is the ratio of the Employment to population ratio(%) in Euro area in 2003 to that in 2005?
Your response must be concise. 0.98. What is the ratio of the Employment to population ratio(%) of Denmark in 2003 to that in 2005?
Provide a short and direct response. 0.98. What is the ratio of the Employment to population ratio(%) in Euro area in 2003 to that in 2006?
Give a very brief answer. 0.96. What is the ratio of the Employment to population ratio(%) in Middle income in 2003 to that in 2006?
Give a very brief answer. 1.01. What is the ratio of the Employment to population ratio(%) of Denmark in 2003 to that in 2006?
Keep it short and to the point. 0.96. What is the ratio of the Employment to population ratio(%) of Uzbekistan in 2003 to that in 2006?
Offer a terse response. 1. What is the ratio of the Employment to population ratio(%) of Euro area in 2003 to that in 2007?
Provide a succinct answer. 0.94. What is the ratio of the Employment to population ratio(%) of Middle income in 2003 to that in 2007?
Provide a short and direct response. 1.02. What is the ratio of the Employment to population ratio(%) of Denmark in 2003 to that in 2007?
Provide a short and direct response. 0.96. What is the ratio of the Employment to population ratio(%) of Uzbekistan in 2003 to that in 2007?
Give a very brief answer. 1. What is the ratio of the Employment to population ratio(%) of Euro area in 2003 to that in 2008?
Offer a terse response. 0.93. What is the ratio of the Employment to population ratio(%) in Middle income in 2003 to that in 2008?
Provide a short and direct response. 1.03. What is the ratio of the Employment to population ratio(%) in Denmark in 2003 to that in 2008?
Make the answer very short. 0.95. What is the ratio of the Employment to population ratio(%) of Euro area in 2003 to that in 2009?
Keep it short and to the point. 0.94. What is the ratio of the Employment to population ratio(%) of Middle income in 2003 to that in 2009?
Offer a terse response. 1.04. What is the ratio of the Employment to population ratio(%) in Denmark in 2003 to that in 2009?
Your response must be concise. 0.98. What is the ratio of the Employment to population ratio(%) in Middle income in 2004 to that in 2005?
Your answer should be very brief. 1. What is the ratio of the Employment to population ratio(%) in Euro area in 2004 to that in 2006?
Offer a very short reply. 0.97. What is the ratio of the Employment to population ratio(%) in Middle income in 2004 to that in 2006?
Your answer should be compact. 1.01. What is the ratio of the Employment to population ratio(%) of Denmark in 2004 to that in 2006?
Your answer should be compact. 0.98. What is the ratio of the Employment to population ratio(%) of Uzbekistan in 2004 to that in 2006?
Provide a short and direct response. 1. What is the ratio of the Employment to population ratio(%) of Euro area in 2004 to that in 2007?
Offer a very short reply. 0.95. What is the ratio of the Employment to population ratio(%) of Middle income in 2004 to that in 2007?
Provide a short and direct response. 1.02. What is the ratio of the Employment to population ratio(%) in Denmark in 2004 to that in 2007?
Ensure brevity in your answer.  0.98. What is the ratio of the Employment to population ratio(%) in Uzbekistan in 2004 to that in 2007?
Provide a short and direct response. 1. What is the ratio of the Employment to population ratio(%) in Euro area in 2004 to that in 2008?
Keep it short and to the point. 0.94. What is the ratio of the Employment to population ratio(%) in Middle income in 2004 to that in 2008?
Give a very brief answer. 1.03. What is the ratio of the Employment to population ratio(%) in Denmark in 2004 to that in 2008?
Keep it short and to the point. 0.97. What is the ratio of the Employment to population ratio(%) of Euro area in 2004 to that in 2009?
Offer a very short reply. 0.95. What is the ratio of the Employment to population ratio(%) in Middle income in 2004 to that in 2009?
Provide a short and direct response. 1.04. What is the ratio of the Employment to population ratio(%) of Euro area in 2005 to that in 2006?
Offer a terse response. 0.98. What is the ratio of the Employment to population ratio(%) of Middle income in 2005 to that in 2006?
Your response must be concise. 1.01. What is the ratio of the Employment to population ratio(%) in Denmark in 2005 to that in 2006?
Make the answer very short. 0.98. What is the ratio of the Employment to population ratio(%) in Euro area in 2005 to that in 2007?
Keep it short and to the point. 0.96. What is the ratio of the Employment to population ratio(%) of Middle income in 2005 to that in 2007?
Keep it short and to the point. 1.01. What is the ratio of the Employment to population ratio(%) of Denmark in 2005 to that in 2007?
Your answer should be very brief. 0.98. What is the ratio of the Employment to population ratio(%) in Euro area in 2005 to that in 2008?
Your response must be concise. 0.95. What is the ratio of the Employment to population ratio(%) of Middle income in 2005 to that in 2008?
Offer a terse response. 1.03. What is the ratio of the Employment to population ratio(%) of Denmark in 2005 to that in 2008?
Ensure brevity in your answer.  0.97. What is the ratio of the Employment to population ratio(%) in Euro area in 2005 to that in 2009?
Provide a short and direct response. 0.96. What is the ratio of the Employment to population ratio(%) of Middle income in 2005 to that in 2009?
Keep it short and to the point. 1.04. What is the ratio of the Employment to population ratio(%) in Euro area in 2006 to that in 2007?
Your answer should be very brief. 0.98. What is the ratio of the Employment to population ratio(%) of Uzbekistan in 2006 to that in 2007?
Provide a succinct answer. 1. What is the ratio of the Employment to population ratio(%) in Euro area in 2006 to that in 2008?
Offer a terse response. 0.97. What is the ratio of the Employment to population ratio(%) in Middle income in 2006 to that in 2008?
Your response must be concise. 1.02. What is the ratio of the Employment to population ratio(%) of Euro area in 2006 to that in 2009?
Offer a terse response. 0.98. What is the ratio of the Employment to population ratio(%) in Middle income in 2006 to that in 2009?
Your answer should be compact. 1.03. What is the ratio of the Employment to population ratio(%) of Denmark in 2006 to that in 2009?
Ensure brevity in your answer.  1.02. What is the ratio of the Employment to population ratio(%) of Uzbekistan in 2006 to that in 2009?
Your answer should be compact. 1. What is the ratio of the Employment to population ratio(%) of Euro area in 2007 to that in 2008?
Offer a terse response. 0.99. What is the ratio of the Employment to population ratio(%) in Middle income in 2007 to that in 2008?
Your answer should be compact. 1.01. What is the ratio of the Employment to population ratio(%) of Denmark in 2007 to that in 2008?
Your response must be concise. 0.99. What is the ratio of the Employment to population ratio(%) in Uzbekistan in 2007 to that in 2008?
Your answer should be very brief. 1. What is the ratio of the Employment to population ratio(%) of Euro area in 2007 to that in 2009?
Offer a terse response. 1. What is the ratio of the Employment to population ratio(%) of Middle income in 2007 to that in 2009?
Give a very brief answer. 1.03. What is the ratio of the Employment to population ratio(%) of Denmark in 2007 to that in 2009?
Your answer should be very brief. 1.02. What is the ratio of the Employment to population ratio(%) in Euro area in 2008 to that in 2009?
Your answer should be compact. 1.01. What is the ratio of the Employment to population ratio(%) of Middle income in 2008 to that in 2009?
Your response must be concise. 1.01. What is the ratio of the Employment to population ratio(%) in Denmark in 2008 to that in 2009?
Your answer should be compact. 1.02. What is the difference between the highest and the second highest Employment to population ratio(%) of Euro area?
Provide a succinct answer. 0.42. What is the difference between the highest and the second highest Employment to population ratio(%) in Middle income?
Your answer should be compact. 0.13. What is the difference between the highest and the second highest Employment to population ratio(%) in Denmark?
Ensure brevity in your answer.  0.4. What is the difference between the highest and the second highest Employment to population ratio(%) of Uzbekistan?
Offer a very short reply. 0. What is the difference between the highest and the lowest Employment to population ratio(%) in Euro area?
Provide a short and direct response. 3.7. What is the difference between the highest and the lowest Employment to population ratio(%) in Middle income?
Your answer should be compact. 2.04. What is the difference between the highest and the lowest Employment to population ratio(%) in Denmark?
Your answer should be very brief. 2.7. What is the difference between the highest and the lowest Employment to population ratio(%) of Uzbekistan?
Offer a terse response. 0.2. 